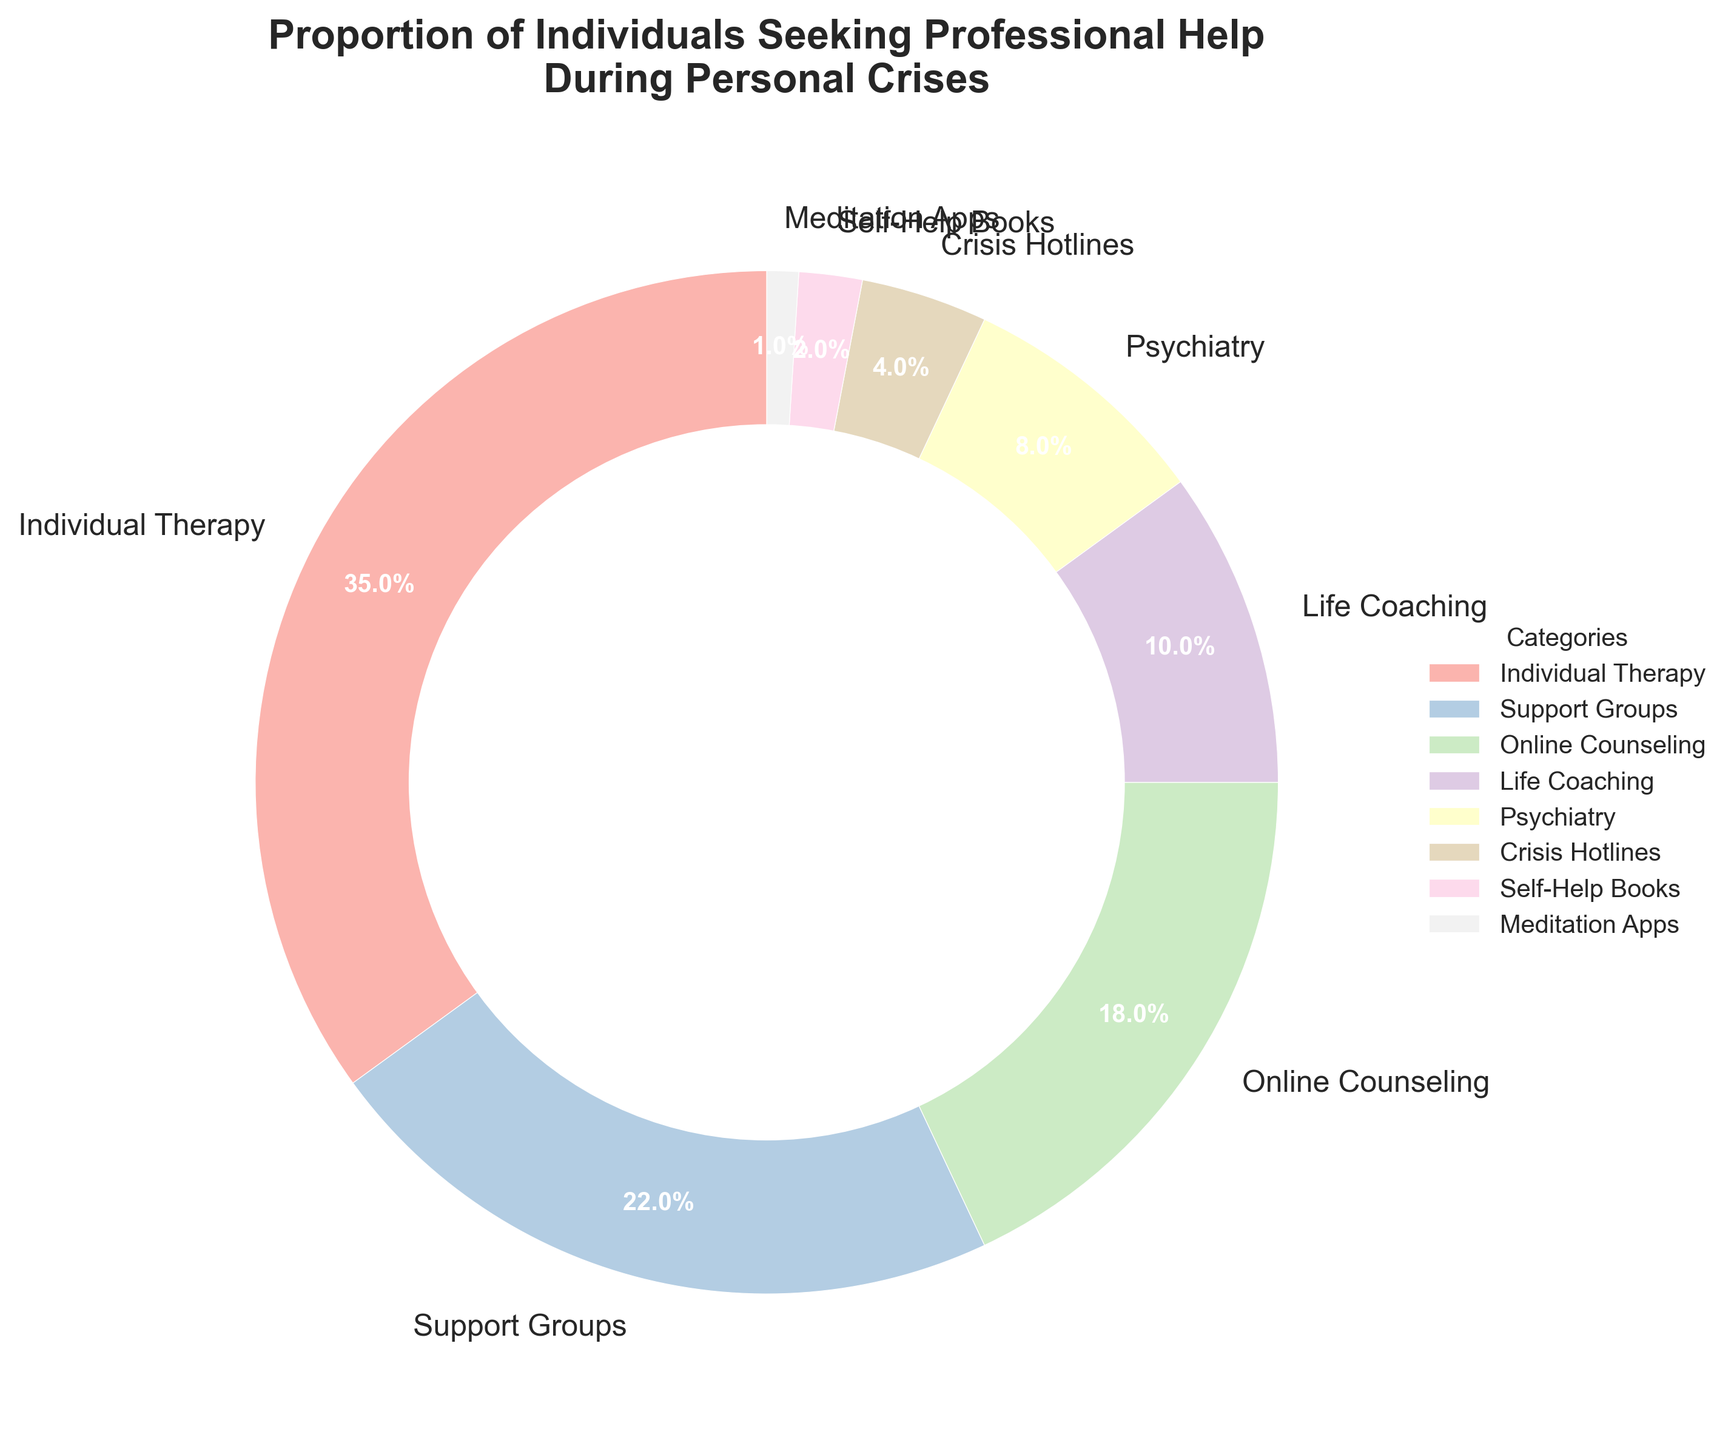Which category has the highest percentage of individuals seeking help? The figure shows the different categories and their corresponding percentages. By looking at the values, we see that "Individual Therapy" has the highest percentage at 35%.
Answer: Individual Therapy Which categories have a combined percentage higher than 50%? To find the combined percentage, we need to sum the percentages of the relevant categories. "Individual Therapy" (35%) and "Support Groups" (22%) together equal 57%, which is higher than 50%.
Answer: Individual Therapy and Support Groups What is the percentage difference between the highest and the lowest category? To find the percentage difference, subtract the percentage of the lowest category from the highest category. "Individual Therapy" is 35% and "Meditation Apps" is 1%. Therefore, the difference is 35% - 1% = 34%.
Answer: 34% Are there more people seeking Life Coaching or Online Counseling? By comparing the percentages, we see that "Online Counseling" has 18%, while "Life Coaching" has 10%. Therefore, more people seek Online Counseling.
Answer: Online Counseling How much more popular is Psychiatry compared to Crisis Hotlines? To find how much more popular Psychiatry is compared to Crisis Hotlines, subtract the percentage of Crisis Hotlines (4%) from Psychiatry (8%). The difference is 8% - 4% = 4%.
Answer: 4% What is the combined percentage for traditional forms of therapy (Individual Therapy and Psychiatry)? Add the percentages of Individual Therapy (35%) and Psychiatry (8%) together. The combined percentage is 35% + 8% = 43%.
Answer: 43% Which category has the least representation on the chart? The figure shows the different categories and their corresponding percentages. The category with the smallest percentage is "Meditation Apps" at 1%.
Answer: Meditation Apps How do Support Groups compare to Self-Help Books in terms of percentage? Support Groups have a percentage of 22%, and Self-Help Books have a percentage of 2%. Comparing these, Support Groups are significantly higher by 20%.
Answer: Support Groups are higher by 20% Are Online Counseling and Life Coaching combined more popular than Individual Therapy alone? Add the percentages of Online Counseling (18%) and Life Coaching (10%): 18% + 10% = 28%. Individual Therapy alone is at 35%. Since 28% is less than 35%, Individual Therapy alone is more popular.
Answer: No What is the total percentage representation of all categories shown in the chart? Sum the percentages of all categories: 35% (Individual Therapy) + 22% (Support Groups) + 18% (Online Counseling) + 10% (Life Coaching) + 8% (Psychiatry) + 4% (Crisis Hotlines) + 2% (Self-Help Books) + 1% (Meditation Apps). The total is 100%.
Answer: 100% 